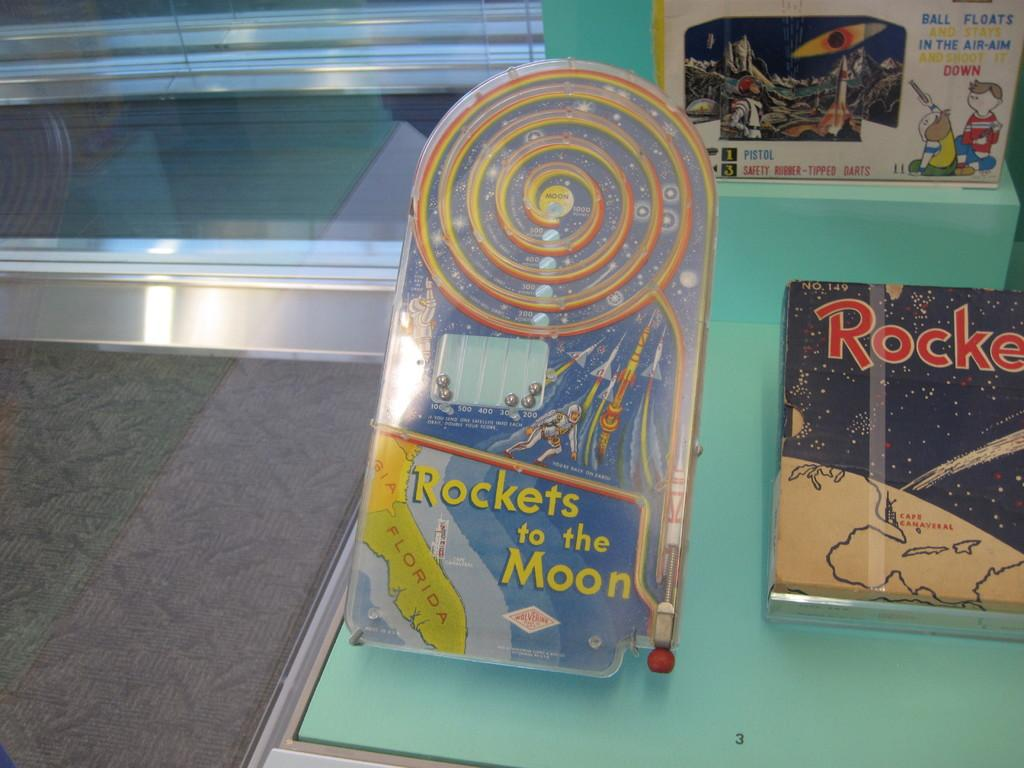Provide a one-sentence caption for the provided image. A children's toy called Rockets to the Moon. 